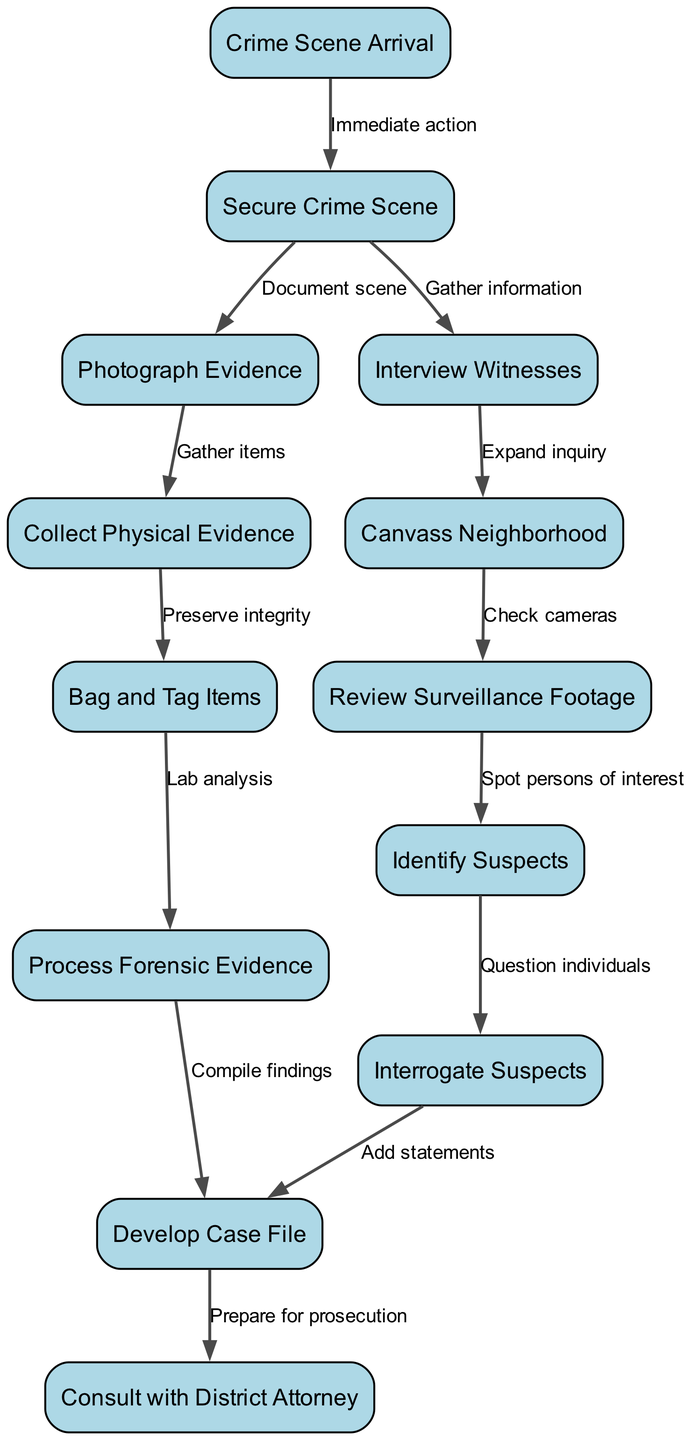What is the starting point of the workflow? The diagram shows "Crime Scene Arrival" as the first node, indicating it is the initial step in the workflow.
Answer: Crime Scene Arrival How many nodes are present in the diagram? By counting each unique node listed in the data, there are 13 nodes that represent different steps in the workflow.
Answer: 13 What is the immediate action after arriving at the crime scene? The edge from "Crime Scene Arrival" to "Secure Crime Scene" is labeled "Immediate action," indicating that securing the scene is the first action taken.
Answer: Secure Crime Scene Which step follows the "Review Surveillance Footage"? The diagram indicates that after "Review Surveillance Footage," the next step is "Identify Suspects," as denoted by the directed edge connecting these nodes.
Answer: Identify Suspects What process is initiated after "Bag and Tag Items"? The edge leading from "Bag and Tag Items" to "Process Forensic Evidence" signifies that processing forensic evidence is the following step once items have been properly labeled and stored.
Answer: Process Forensic Evidence How many edges connect the "Interview Witnesses" node? After examining the edges connected to the "Interview Witnesses" node, it is seen that there is one outgoing edge directing to "Canvass Neighborhood," indicating it is connected by a single edge.
Answer: 1 In the sequence of actions, what is the last step before consulting the District Attorney? The final step prior to "Consult with District Attorney" is "Develop Case File," which compiles all information necessary for legal proceedings.
Answer: Develop Case File What type of evidence is collected after photographing evidence? The directed edge leading from "Photograph Evidence" to "Collect Physical Evidence" specifies that physical evidence is gathered after photographing the crime scene.
Answer: Physical Evidence Which actions are involved in gathering information at the crime scene? The diagram shows that "Secure Crime Scene" leads to both "Photograph Evidence" and "Interview Witnesses." Therefore, both actions are involved in gathering information right after securing the scene.
Answer: Photograph Evidence, Interview Witnesses 